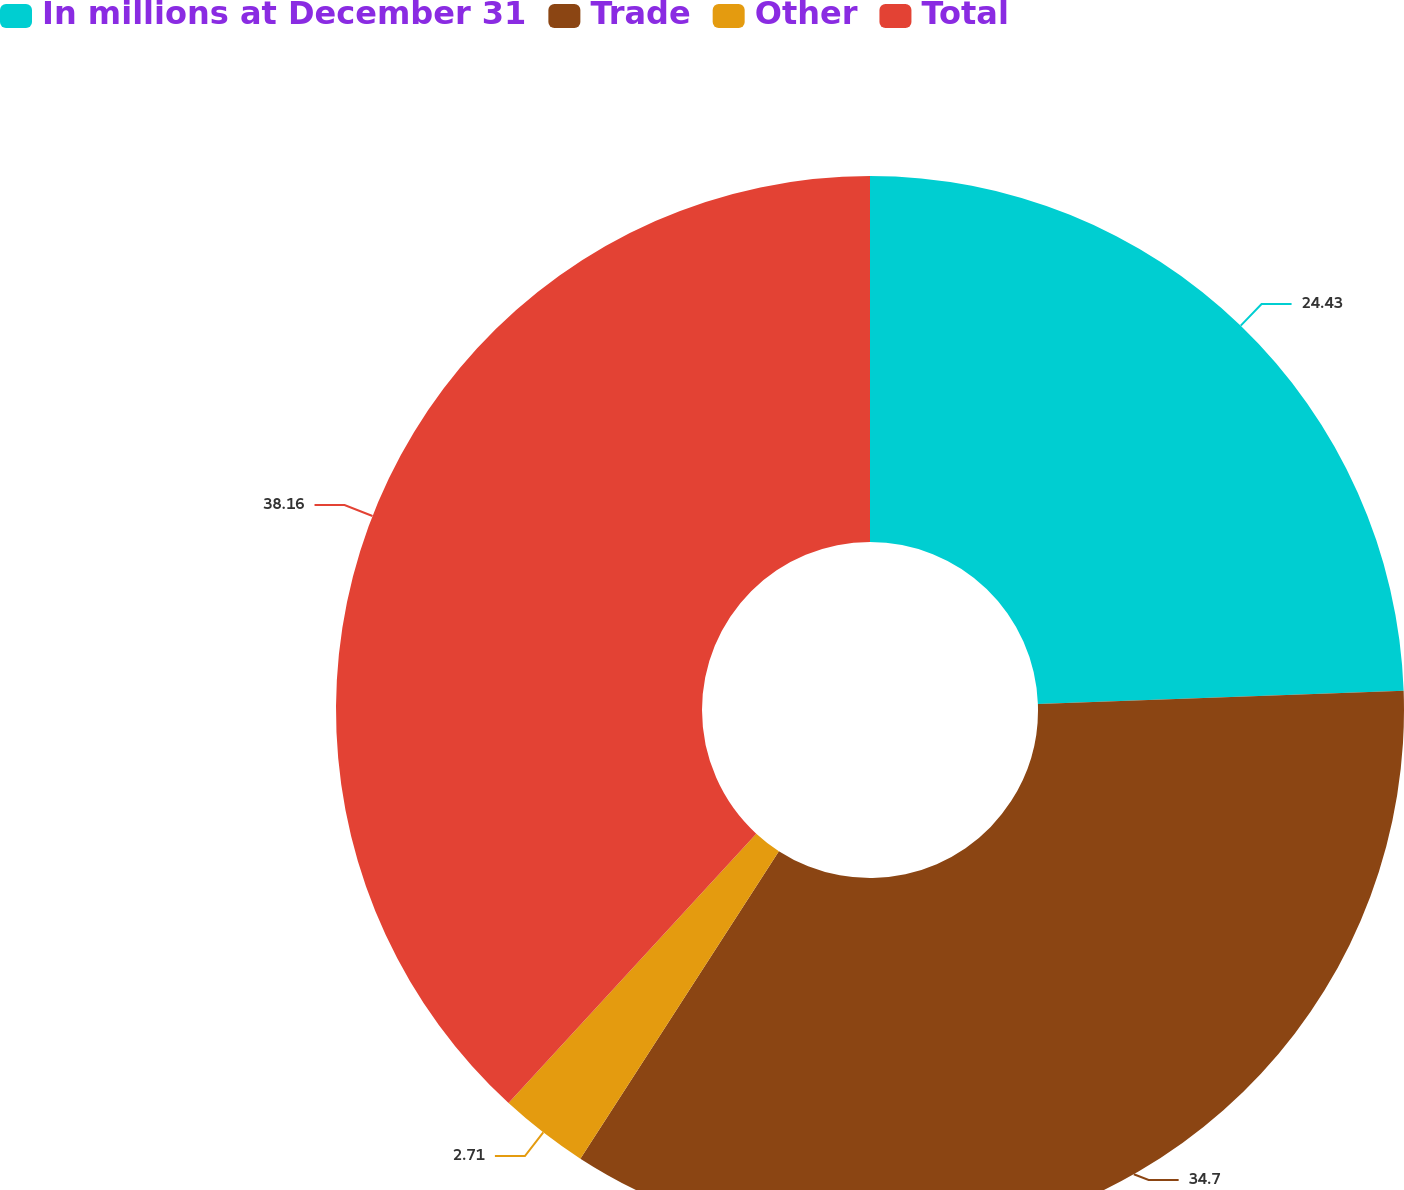Convert chart to OTSL. <chart><loc_0><loc_0><loc_500><loc_500><pie_chart><fcel>In millions at December 31<fcel>Trade<fcel>Other<fcel>Total<nl><fcel>24.43%<fcel>34.7%<fcel>2.71%<fcel>38.17%<nl></chart> 